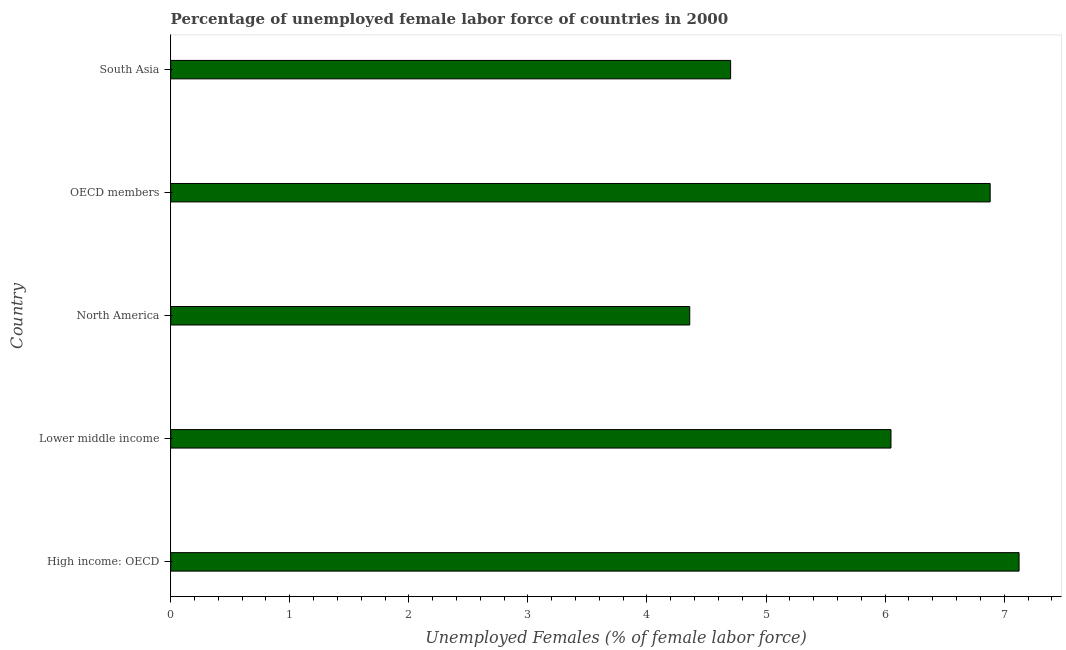Does the graph contain grids?
Provide a short and direct response. No. What is the title of the graph?
Give a very brief answer. Percentage of unemployed female labor force of countries in 2000. What is the label or title of the X-axis?
Offer a terse response. Unemployed Females (% of female labor force). What is the total unemployed female labour force in Lower middle income?
Your answer should be compact. 6.05. Across all countries, what is the maximum total unemployed female labour force?
Your answer should be compact. 7.12. Across all countries, what is the minimum total unemployed female labour force?
Your answer should be very brief. 4.36. In which country was the total unemployed female labour force maximum?
Ensure brevity in your answer.  High income: OECD. In which country was the total unemployed female labour force minimum?
Make the answer very short. North America. What is the sum of the total unemployed female labour force?
Your response must be concise. 29.12. What is the difference between the total unemployed female labour force in High income: OECD and Lower middle income?
Offer a terse response. 1.08. What is the average total unemployed female labour force per country?
Your answer should be very brief. 5.82. What is the median total unemployed female labour force?
Provide a short and direct response. 6.05. In how many countries, is the total unemployed female labour force greater than 6.2 %?
Your response must be concise. 2. What is the ratio of the total unemployed female labour force in Lower middle income to that in OECD members?
Your response must be concise. 0.88. Is the difference between the total unemployed female labour force in North America and South Asia greater than the difference between any two countries?
Keep it short and to the point. No. What is the difference between the highest and the second highest total unemployed female labour force?
Your answer should be compact. 0.24. What is the difference between the highest and the lowest total unemployed female labour force?
Keep it short and to the point. 2.77. How many bars are there?
Your answer should be very brief. 5. How many countries are there in the graph?
Provide a short and direct response. 5. What is the difference between two consecutive major ticks on the X-axis?
Offer a terse response. 1. What is the Unemployed Females (% of female labor force) in High income: OECD?
Offer a terse response. 7.12. What is the Unemployed Females (% of female labor force) in Lower middle income?
Make the answer very short. 6.05. What is the Unemployed Females (% of female labor force) in North America?
Provide a short and direct response. 4.36. What is the Unemployed Females (% of female labor force) in OECD members?
Offer a very short reply. 6.88. What is the Unemployed Females (% of female labor force) in South Asia?
Provide a short and direct response. 4.7. What is the difference between the Unemployed Females (% of female labor force) in High income: OECD and Lower middle income?
Make the answer very short. 1.08. What is the difference between the Unemployed Females (% of female labor force) in High income: OECD and North America?
Your answer should be compact. 2.77. What is the difference between the Unemployed Females (% of female labor force) in High income: OECD and OECD members?
Make the answer very short. 0.24. What is the difference between the Unemployed Females (% of female labor force) in High income: OECD and South Asia?
Offer a very short reply. 2.42. What is the difference between the Unemployed Females (% of female labor force) in Lower middle income and North America?
Your response must be concise. 1.69. What is the difference between the Unemployed Females (% of female labor force) in Lower middle income and OECD members?
Your answer should be compact. -0.83. What is the difference between the Unemployed Females (% of female labor force) in Lower middle income and South Asia?
Provide a succinct answer. 1.35. What is the difference between the Unemployed Females (% of female labor force) in North America and OECD members?
Make the answer very short. -2.52. What is the difference between the Unemployed Females (% of female labor force) in North America and South Asia?
Make the answer very short. -0.34. What is the difference between the Unemployed Females (% of female labor force) in OECD members and South Asia?
Ensure brevity in your answer.  2.18. What is the ratio of the Unemployed Females (% of female labor force) in High income: OECD to that in Lower middle income?
Your response must be concise. 1.18. What is the ratio of the Unemployed Females (% of female labor force) in High income: OECD to that in North America?
Your response must be concise. 1.63. What is the ratio of the Unemployed Females (% of female labor force) in High income: OECD to that in OECD members?
Give a very brief answer. 1.03. What is the ratio of the Unemployed Females (% of female labor force) in High income: OECD to that in South Asia?
Provide a succinct answer. 1.51. What is the ratio of the Unemployed Females (% of female labor force) in Lower middle income to that in North America?
Provide a succinct answer. 1.39. What is the ratio of the Unemployed Females (% of female labor force) in Lower middle income to that in OECD members?
Offer a terse response. 0.88. What is the ratio of the Unemployed Females (% of female labor force) in Lower middle income to that in South Asia?
Your answer should be very brief. 1.29. What is the ratio of the Unemployed Females (% of female labor force) in North America to that in OECD members?
Provide a succinct answer. 0.63. What is the ratio of the Unemployed Females (% of female labor force) in North America to that in South Asia?
Give a very brief answer. 0.93. What is the ratio of the Unemployed Females (% of female labor force) in OECD members to that in South Asia?
Your answer should be compact. 1.46. 